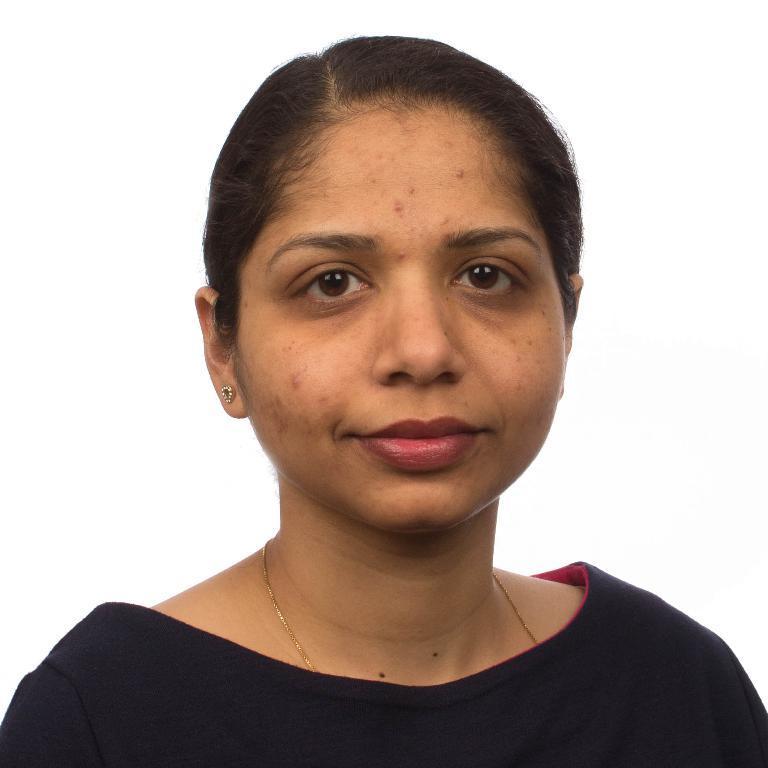Please provide a concise description of this image. In this picture I can observe a woman wearing black color dress. She is smiling. The background is in white color. 